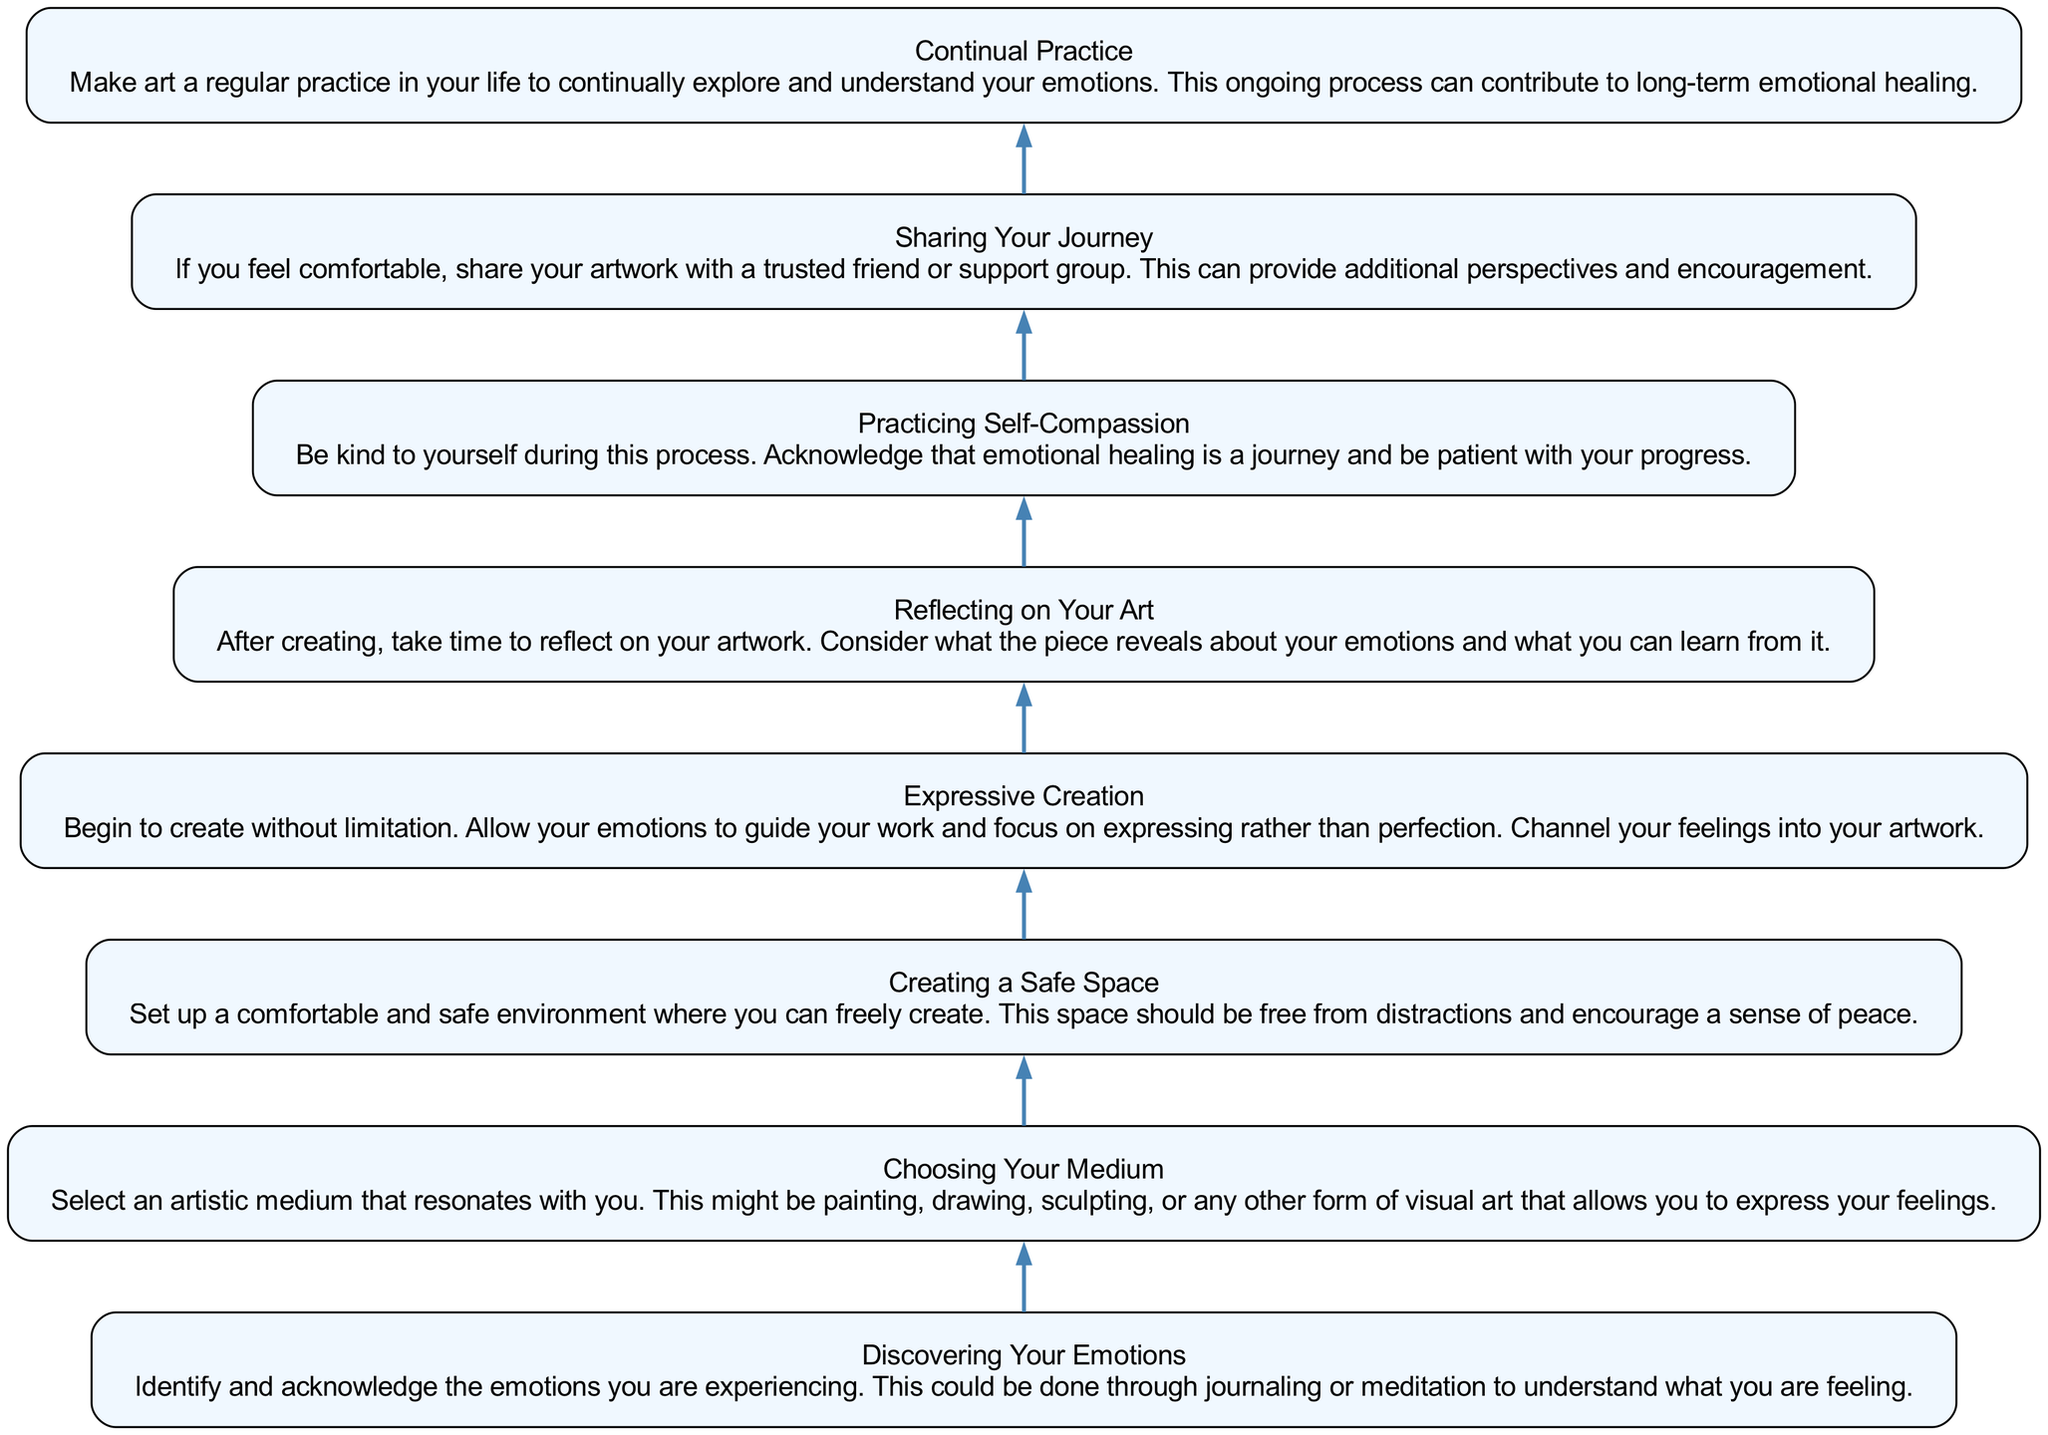What is the first step in the diagram? The flow chart starts with the first step labeled "Discovering Your Emotions." This is the initial node in the upward flow of the diagram, indicating the starting point for emotional healing through art.
Answer: Discovering Your Emotions How many total steps are there in the diagram? By counting all the nodes listed in the flow chart, there are eight distinct steps that guide the process of emotional healing through art.
Answer: Eight What is the last step in the flow chart? The final node at the top of the diagram is "Continual Practice," which signifies the ongoing nature of emotional healing through artistic expression.
Answer: Continual Practice What step comes directly before "Reflecting on Your Art"? The node directly leading into "Reflecting on Your Art" is "Expressive Creation," indicating that creation should occur before reflecting on the artwork produced.
Answer: Expressive Creation What does the "Sharing Your Journey" step encourage? This step encourages individuals to share their artwork with a trusted friend or support group, suggesting that sharing can provide support and feedback.
Answer: Sharing artwork Which step emphasizes self-kindness? The step labeled "Practicing Self-Compassion" emphasizes the need for self-kindness and patience during the emotional healing journey through art.
Answer: Practicing Self-Compassion What medium can be chosen according to the diagram? The flow chart suggests choosing any artistic medium, such as painting, drawing, or sculpting, that resonates personally for expressing feelings.
Answer: Any artistic medium What are the steps of expressive creation and reflection mainly about? These steps focus on the active expression of emotions through art and the subsequent reflection on the created artwork for deeper understanding.
Answer: Expressive Creation and Reflection What is the purpose of creating a safe space? The purpose of creating a safe space is to ensure a comfortable and distraction-free environment that encourages peaceful and authentic artistic expression.
Answer: Comfortable and distraction-free environment 